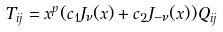Convert formula to latex. <formula><loc_0><loc_0><loc_500><loc_500>T _ { i j } = x ^ { p } ( c _ { 1 } J _ { \nu } ( x ) + c _ { 2 } J _ { - \nu } ( x ) ) Q _ { i j }</formula> 